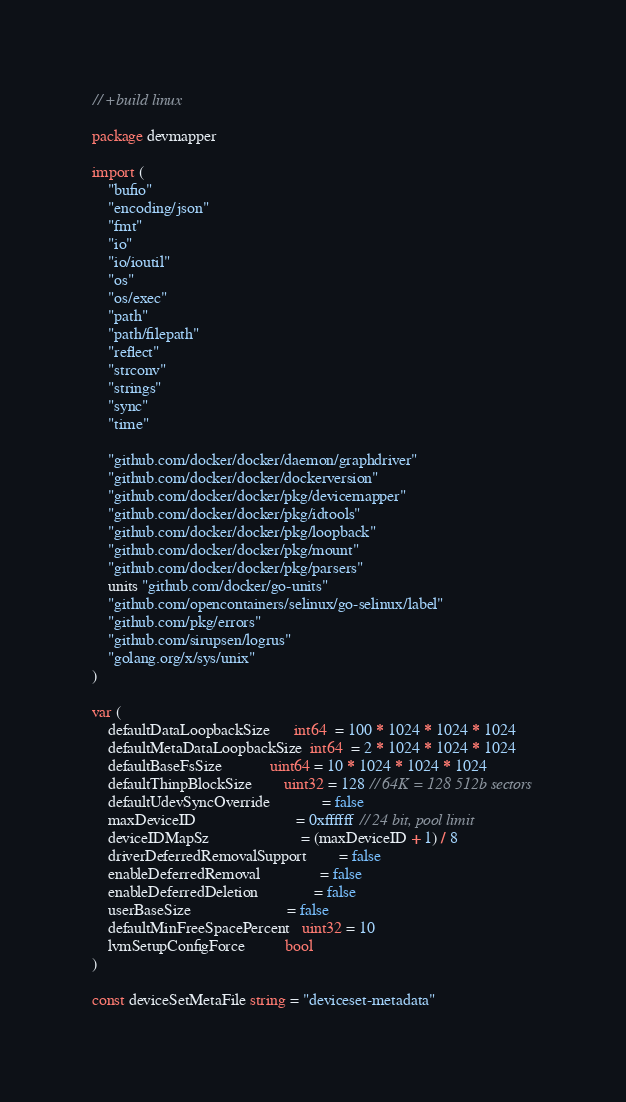<code> <loc_0><loc_0><loc_500><loc_500><_Go_>// +build linux

package devmapper

import (
	"bufio"
	"encoding/json"
	"fmt"
	"io"
	"io/ioutil"
	"os"
	"os/exec"
	"path"
	"path/filepath"
	"reflect"
	"strconv"
	"strings"
	"sync"
	"time"

	"github.com/docker/docker/daemon/graphdriver"
	"github.com/docker/docker/dockerversion"
	"github.com/docker/docker/pkg/devicemapper"
	"github.com/docker/docker/pkg/idtools"
	"github.com/docker/docker/pkg/loopback"
	"github.com/docker/docker/pkg/mount"
	"github.com/docker/docker/pkg/parsers"
	units "github.com/docker/go-units"
	"github.com/opencontainers/selinux/go-selinux/label"
	"github.com/pkg/errors"
	"github.com/sirupsen/logrus"
	"golang.org/x/sys/unix"
)

var (
	defaultDataLoopbackSize      int64  = 100 * 1024 * 1024 * 1024
	defaultMetaDataLoopbackSize  int64  = 2 * 1024 * 1024 * 1024
	defaultBaseFsSize            uint64 = 10 * 1024 * 1024 * 1024
	defaultThinpBlockSize        uint32 = 128 // 64K = 128 512b sectors
	defaultUdevSyncOverride             = false
	maxDeviceID                         = 0xffffff // 24 bit, pool limit
	deviceIDMapSz                       = (maxDeviceID + 1) / 8
	driverDeferredRemovalSupport        = false
	enableDeferredRemoval               = false
	enableDeferredDeletion              = false
	userBaseSize                        = false
	defaultMinFreeSpacePercent   uint32 = 10
	lvmSetupConfigForce          bool
)

const deviceSetMetaFile string = "deviceset-metadata"</code> 